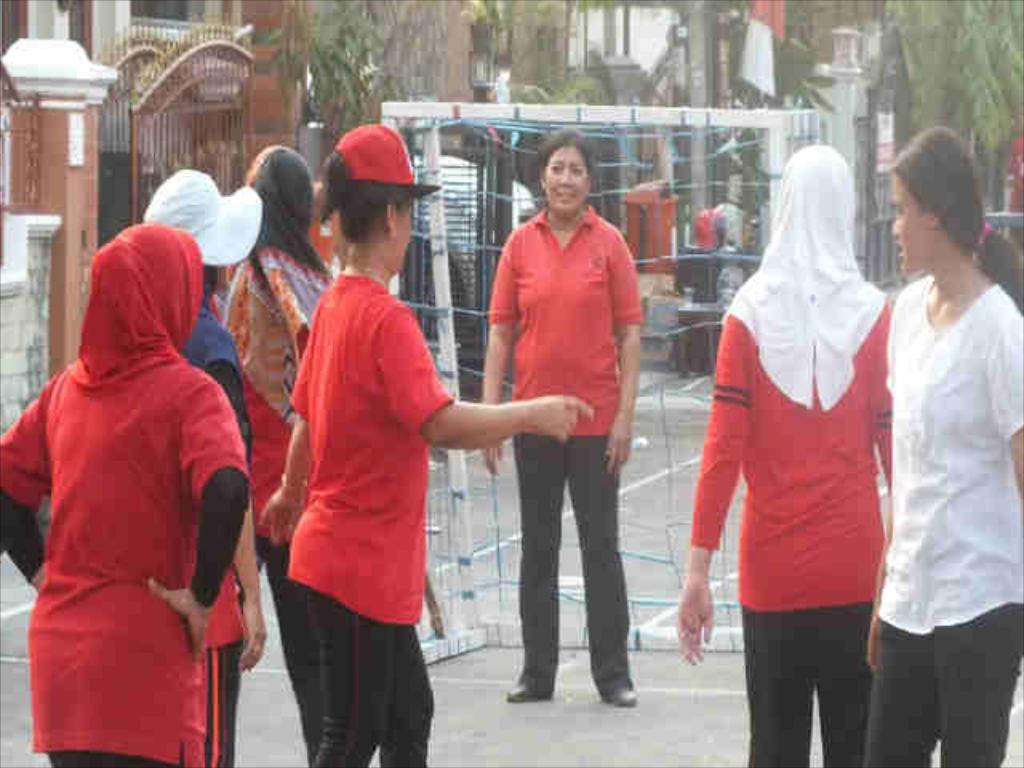Who or what can be seen in the image? There are people in the image. What type of natural elements are present in the image? There are trees in the image. What type of structures can be seen in the image? There are gates and buildings in the image. What type of quince is being served at the party in the image? There is no party or quince present in the image. What type of root can be seen growing near the gates in the image? There is no root visible in the image; only trees, gates, and buildings are present. 